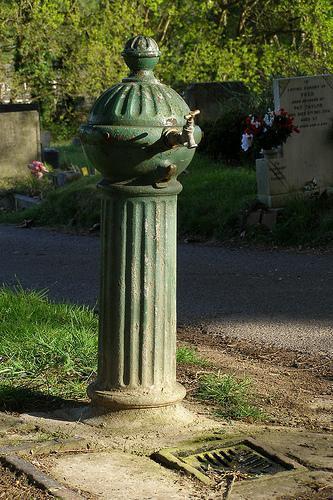How many grave markers are visible to the right of the spigot holder?
Give a very brief answer. 2. 